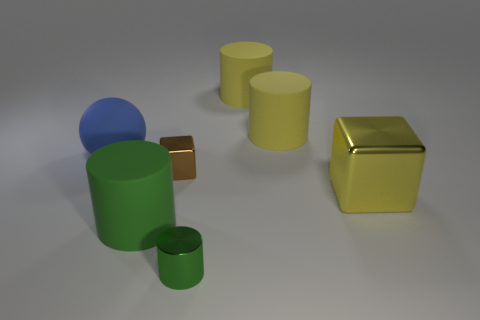The metallic object in front of the large rubber cylinder that is in front of the big metallic thing is what color? green 